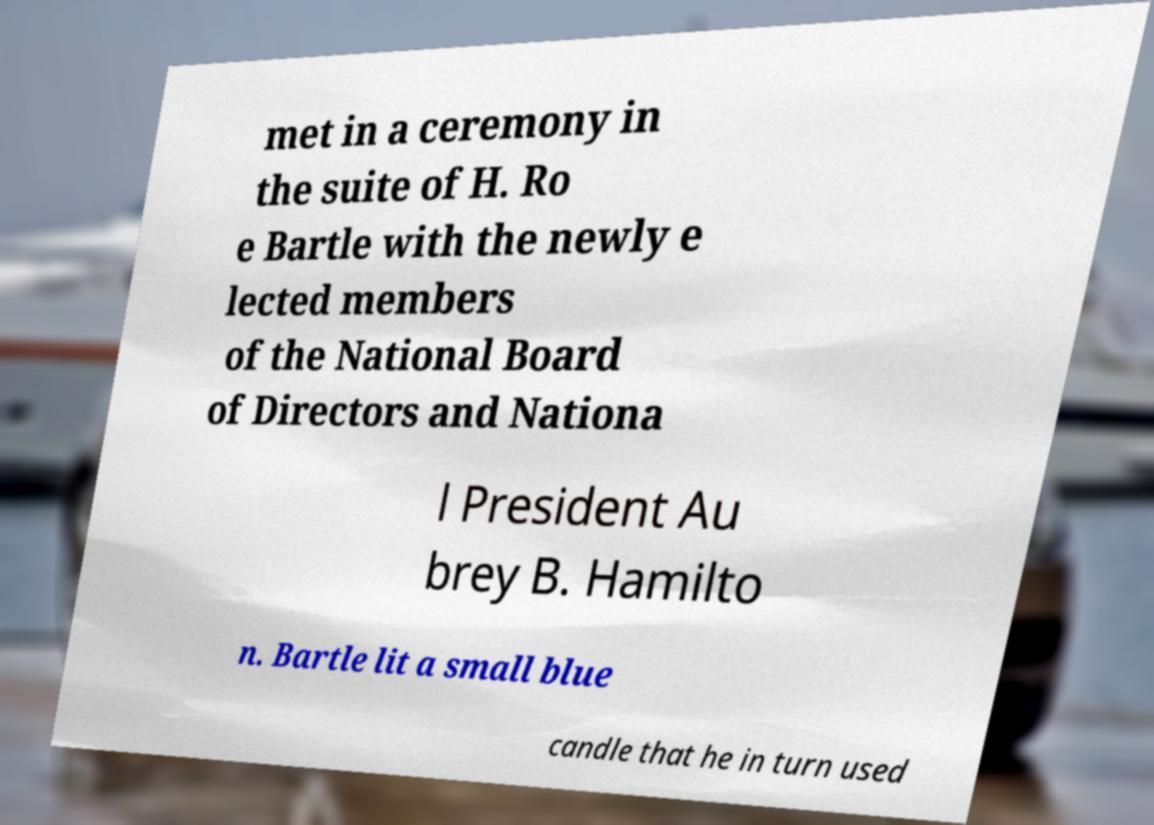I need the written content from this picture converted into text. Can you do that? met in a ceremony in the suite of H. Ro e Bartle with the newly e lected members of the National Board of Directors and Nationa l President Au brey B. Hamilto n. Bartle lit a small blue candle that he in turn used 